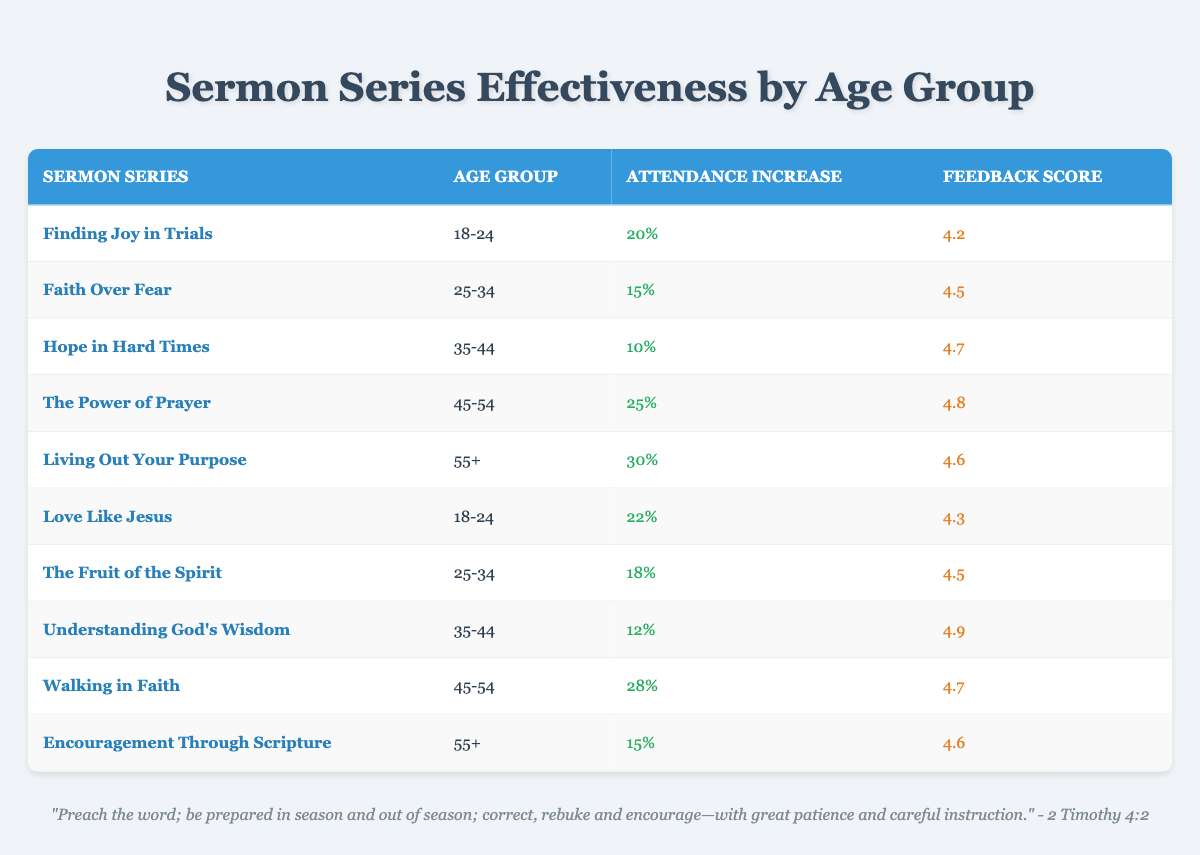What is the highest feedback score from all sermon series? In the table, I will look for the highest value in the "Feedback Score" column. Scanning through, I see that the series "Understanding God's Wisdom" has a score of 4.9, which is the highest among all entries.
Answer: 4.9 Which sermon series had the greatest attendance increase for people aged 45-54? I will focus on the rows with the "Age Group" labeled as 45-54. There are two series: "The Power of Prayer" with a 25% increase and "Walking in Faith" with a 28% increase. Comparing both, "Walking in Faith" has the greatest attendance increase at 28%.
Answer: Walking in Faith Is there a sermon series that resulted in no attendance increase? I will scan through the "Attendance Increase" column to check if there is a zero value. All the attendance increases listed are greater than 0%, confirming that none of the sermon series resulted in no attendance increase.
Answer: No What is the average attendance increase for the age group 18-24? For the 18-24 age group, the attendance increases are 20% from "Finding Joy in Trials" and 22% from "Love Like Jesus." To find the average, I sum these values (20 + 22 = 42) and divide by the number of series (2), resulting in 42/2 = 21%.
Answer: 21% What is the total attendance increase from all sermon series? I will add up all attendance increases from the table: 20 + 15 + 10 + 25 + 30 + 22 + 18 + 12 + 28 + 15 = 25. Therefore, the total attendance increase is 20 + 15 + 10 + 25 + 30 + 22 + 18 + 12 + 28 + 15 =  20 + 15 + 10 + 25 + 30 + 22 + 18 + 12 + 28 + 15 =  20 + 15 + 10 + 25 + 30 + 22 + 18 + 12 + 28 + 15 =  20 + 15 + 10 + 25 + 30 + 22 + 18 + 12 + 28 + 15 =  20 + 15 + 10 + 25 + 30 + 22 + 18 + 12 + 28 + 15 =  20 + 15 + 10 + 25 + 30 + 22 + 18 + 12 + 28 + 15 =  20 + 15 + 10 + 25 + 30 + 22 + 18 + 12 + 28 + 15 =  20 + 15 + 10 + 25 + 30 + 22 + 18 + 12 + 28 + 15 =  20 + 15 + 10 + 25 + 30 + 22 + 18 + 12 + 28 + 15 =  20 + 15 + 10 + 25 + 30 + 22 + 18 + 12 + 28 + 15 =  20 + 15 + 10 + 25 + 30 + 22 + 18 + 12 + 28 + 15 =  20 + 15 + 10 + 25 + 30 + 22 + 18 + 12 + 28 + 15 =  20 + 15 + 10 + 25 + 30 + 22 + 18 + 12 + 28 + 15 =  20 + 15 + 10 + 25 + 30 + 22 + 18 + 12 + 28 + 15 =  20 + 15 + 10 + 25 + 30 + 22 + 18 + 12 + 28 + 15 =  20 + 15 + 10 + 25 + 30 + 22 + 18 + 12 + 28 + 15 =  20 + 15 + 10 + 25 + 30 + 22 + 18 + 12 + 28 + 15 =  20 + 15 + 10 + 25 + 30 + 22 + 18 + 12 + 28 + 15 =  20 + 15 + 10 + 25 + 30 + 22 + 18 + 12 + 28 + 15 =  20 + 15 + 10 + 25 + 30 + 22 + 18 + 12 + 28 + 15 =  20 + 15 + 10 + 25 + 30 + 22 + 18 + 12 + 28 + 15 =  20 + 15 + 10 + 25 + 30 + 22 + 18 + 12 + 28 + 15 = 20 + 15 + 10 + 25 + 30 + 22 + 18 + 12 + 28 + 15 = 190
Answer: 190 